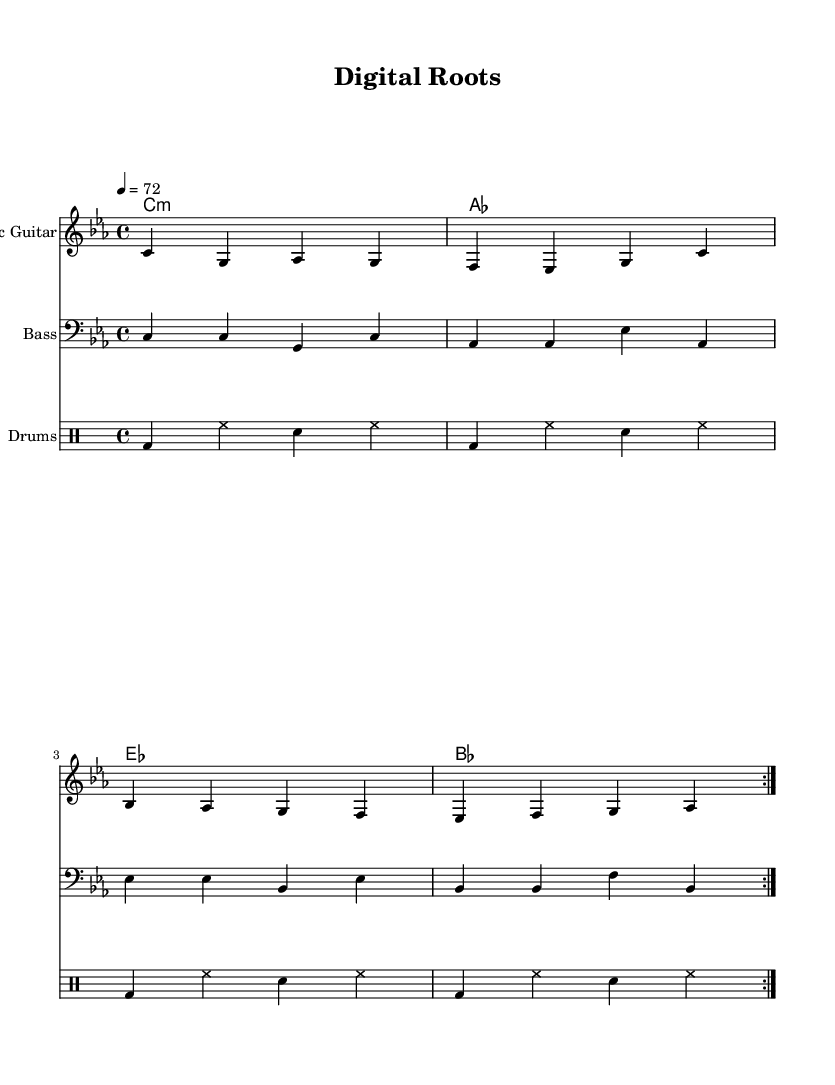What is the key signature of this music? The key signature is indicated at the beginning of the score and shows that there are no sharps or flats, meaning it is in C minor.
Answer: C minor What is the time signature of this music? The time signature is located at the beginning of the score, which indicates a 4/4 meter, meaning there are four beats per measure, and the quarter note receives one beat.
Answer: 4/4 What is the tempo marking of this music? The tempo marking is specified as a quarter note equals 72 beats per minute at the beginning of the score, indicating a moderate speed.
Answer: 72 How many measures are repeated in the electric guitar part? The electric guitar section shows a repeat sign (volta) that indicates the first two measures are repeated, leading to a total of two cycles through all four measures.
Answer: 2 What instrument is playing the bass part? The score indicates that a "Bass" staff is included, which is typical for a bass guitar in a reggae context.
Answer: Bass What type of music does this sheet represent? The overall structure, the instrumentation, and the laid-back groove characteristics in the rhythms suggest that it is reggae music, specifically roots reggae focusing on cultural and technological themes.
Answer: Reggae 